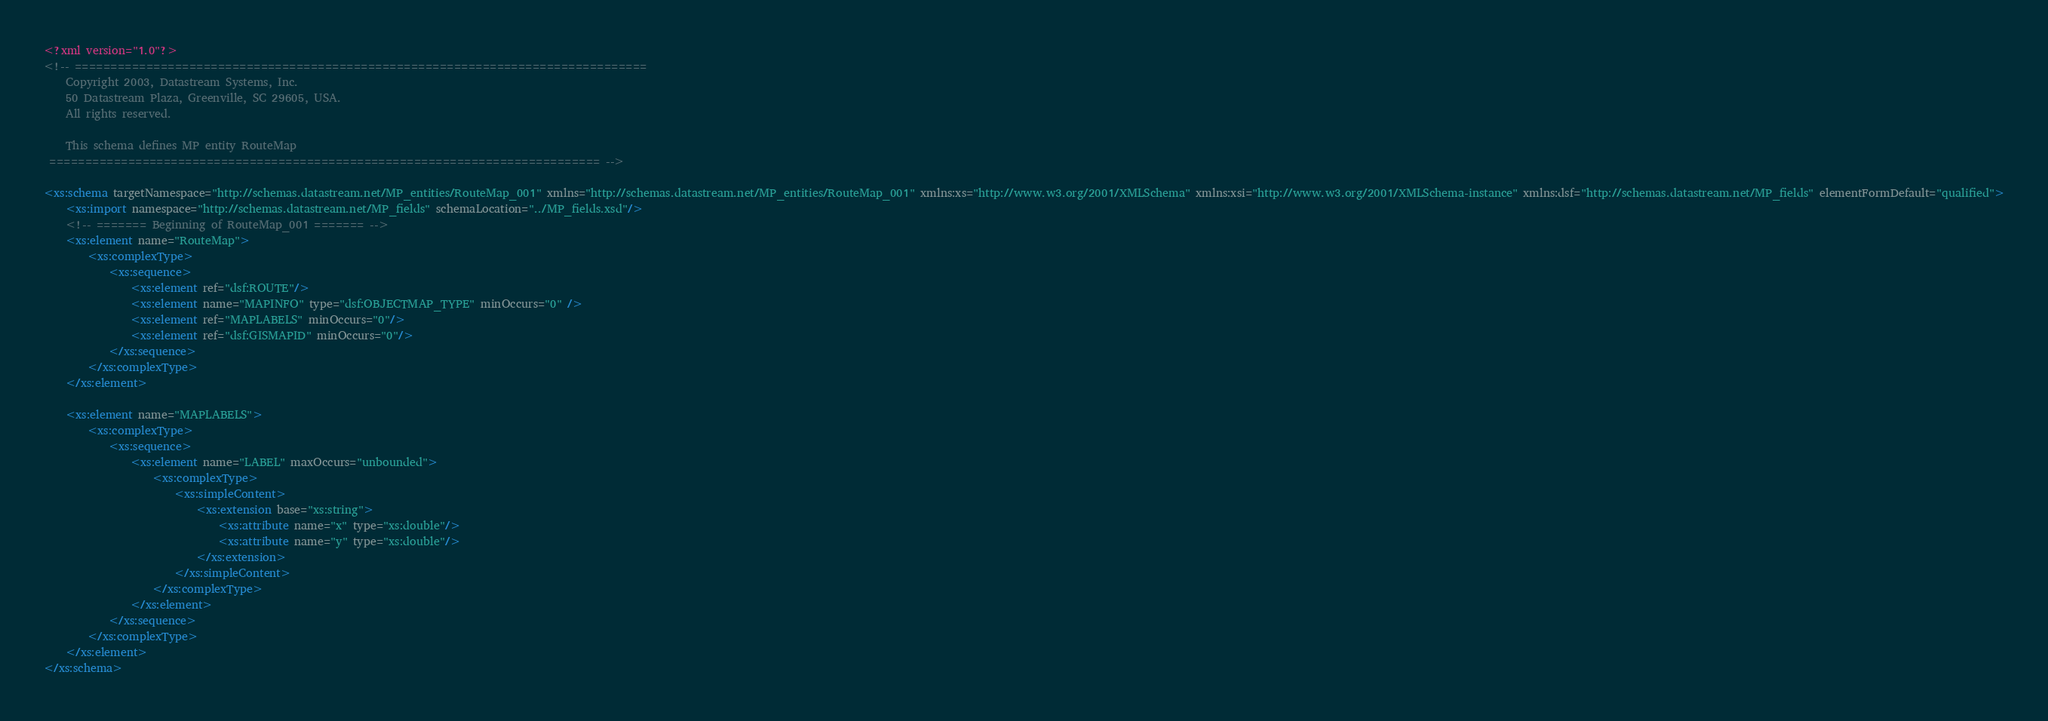Convert code to text. <code><loc_0><loc_0><loc_500><loc_500><_XML_><?xml version="1.0"?>
<!-- ================================================================================
    Copyright 2003, Datastream Systems, Inc.
    50 Datastream Plaza, Greenville, SC 29605, USA.
    All rights reserved.

    This schema defines MP entity RouteMap
 ============================================================================= -->

<xs:schema targetNamespace="http://schemas.datastream.net/MP_entities/RouteMap_001" xmlns="http://schemas.datastream.net/MP_entities/RouteMap_001" xmlns:xs="http://www.w3.org/2001/XMLSchema" xmlns:xsi="http://www.w3.org/2001/XMLSchema-instance" xmlns:dsf="http://schemas.datastream.net/MP_fields" elementFormDefault="qualified">
	<xs:import namespace="http://schemas.datastream.net/MP_fields" schemaLocation="../MP_fields.xsd"/>
	<!-- ======= Beginning of RouteMap_001 ======= -->
	<xs:element name="RouteMap">
		<xs:complexType>
			<xs:sequence>
				<xs:element ref="dsf:ROUTE"/>
 				<xs:element name="MAPINFO" type="dsf:OBJECTMAP_TYPE" minOccurs="0" />
				<xs:element ref="MAPLABELS" minOccurs="0"/>
				<xs:element ref="dsf:GISMAPID" minOccurs="0"/>
			</xs:sequence>
		</xs:complexType>
	</xs:element>

	<xs:element name="MAPLABELS">
		<xs:complexType>
			<xs:sequence>
				<xs:element name="LABEL" maxOccurs="unbounded">
					<xs:complexType>
						<xs:simpleContent>
							<xs:extension base="xs:string">
								<xs:attribute name="x" type="xs:double"/>
								<xs:attribute name="y" type="xs:double"/>
							</xs:extension>
						</xs:simpleContent>
					</xs:complexType>
				</xs:element>
			</xs:sequence>
		</xs:complexType>
	</xs:element>
</xs:schema>
</code> 